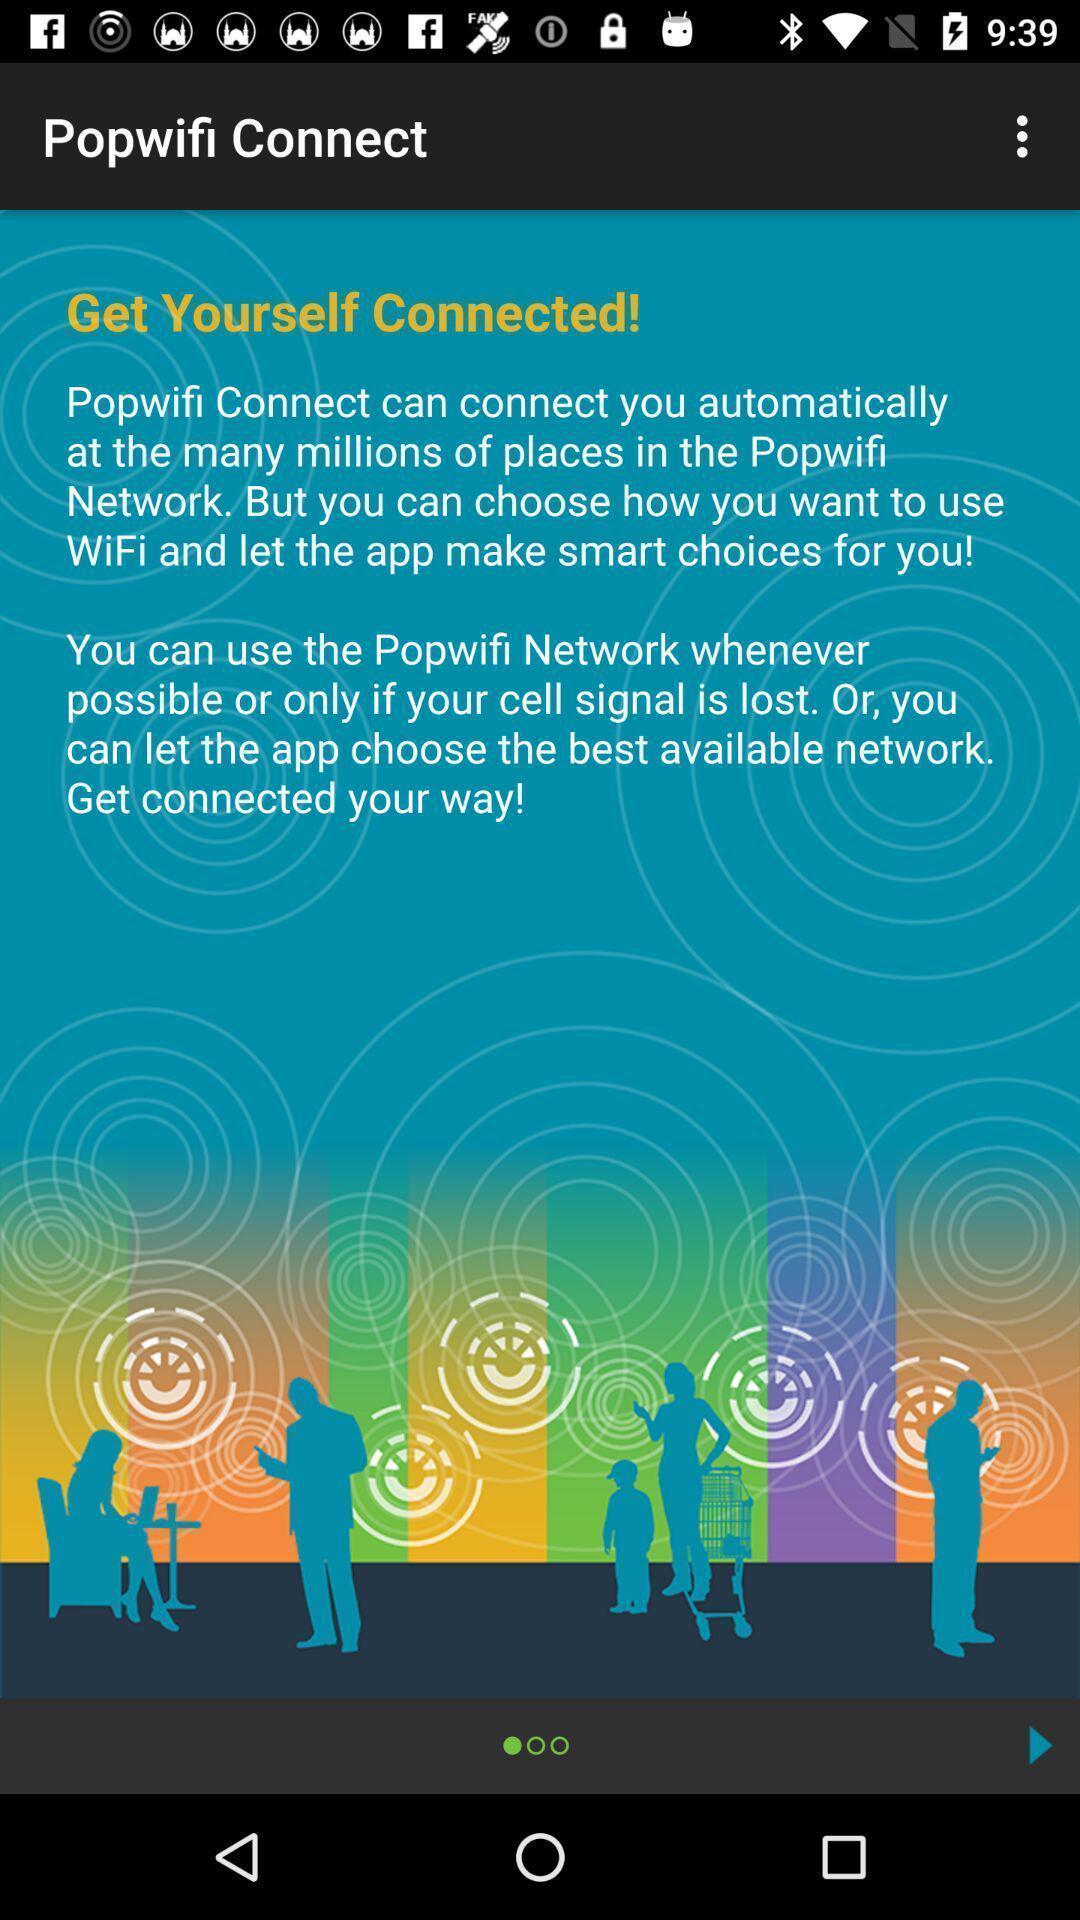Tell me about the visual elements in this screen capture. Welcome page. 